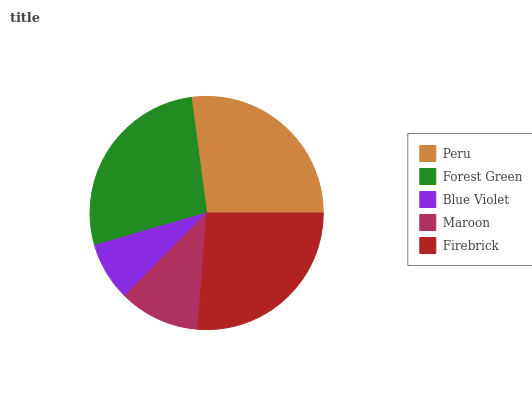Is Blue Violet the minimum?
Answer yes or no. Yes. Is Forest Green the maximum?
Answer yes or no. Yes. Is Forest Green the minimum?
Answer yes or no. No. Is Blue Violet the maximum?
Answer yes or no. No. Is Forest Green greater than Blue Violet?
Answer yes or no. Yes. Is Blue Violet less than Forest Green?
Answer yes or no. Yes. Is Blue Violet greater than Forest Green?
Answer yes or no. No. Is Forest Green less than Blue Violet?
Answer yes or no. No. Is Firebrick the high median?
Answer yes or no. Yes. Is Firebrick the low median?
Answer yes or no. Yes. Is Blue Violet the high median?
Answer yes or no. No. Is Peru the low median?
Answer yes or no. No. 